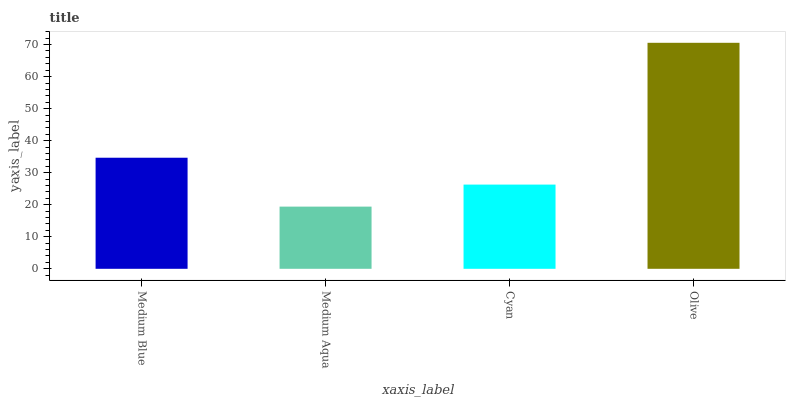Is Medium Aqua the minimum?
Answer yes or no. Yes. Is Olive the maximum?
Answer yes or no. Yes. Is Cyan the minimum?
Answer yes or no. No. Is Cyan the maximum?
Answer yes or no. No. Is Cyan greater than Medium Aqua?
Answer yes or no. Yes. Is Medium Aqua less than Cyan?
Answer yes or no. Yes. Is Medium Aqua greater than Cyan?
Answer yes or no. No. Is Cyan less than Medium Aqua?
Answer yes or no. No. Is Medium Blue the high median?
Answer yes or no. Yes. Is Cyan the low median?
Answer yes or no. Yes. Is Cyan the high median?
Answer yes or no. No. Is Olive the low median?
Answer yes or no. No. 